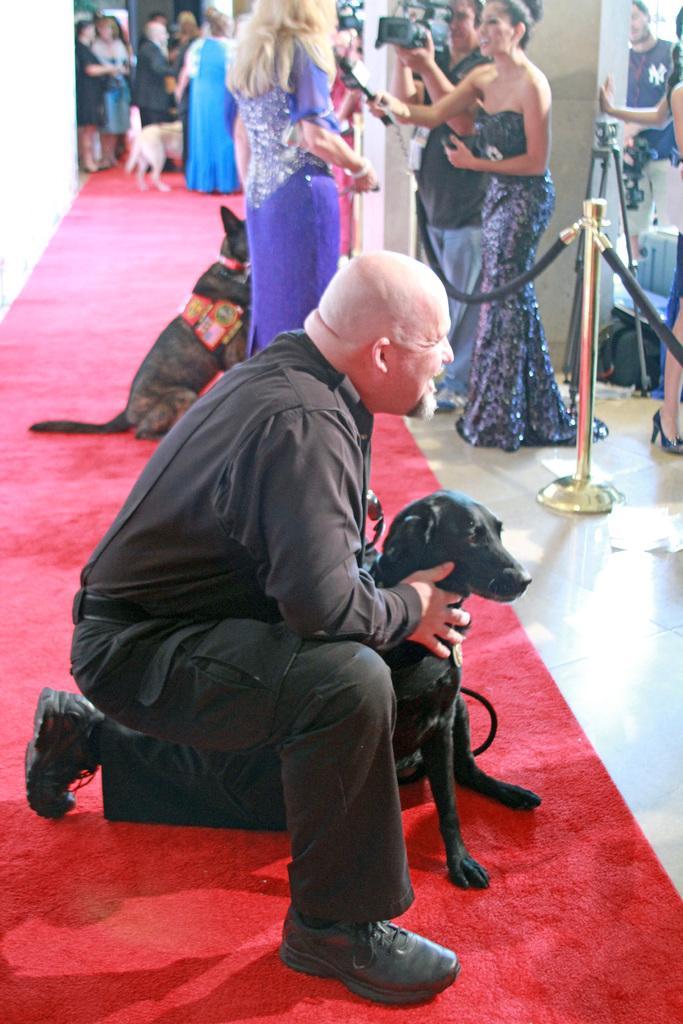Can you describe this image briefly? In this image we can see a man is sitting on a red carpet wearing black color shirt and pant and holding black color dog, posing for photograph. Behind a lady is standing and giving interview. And wearing purple color dress. In front of her one more lady is standing, holding mic in her hand and one man is there, holding camera in his hand. Background of the image people are there. 